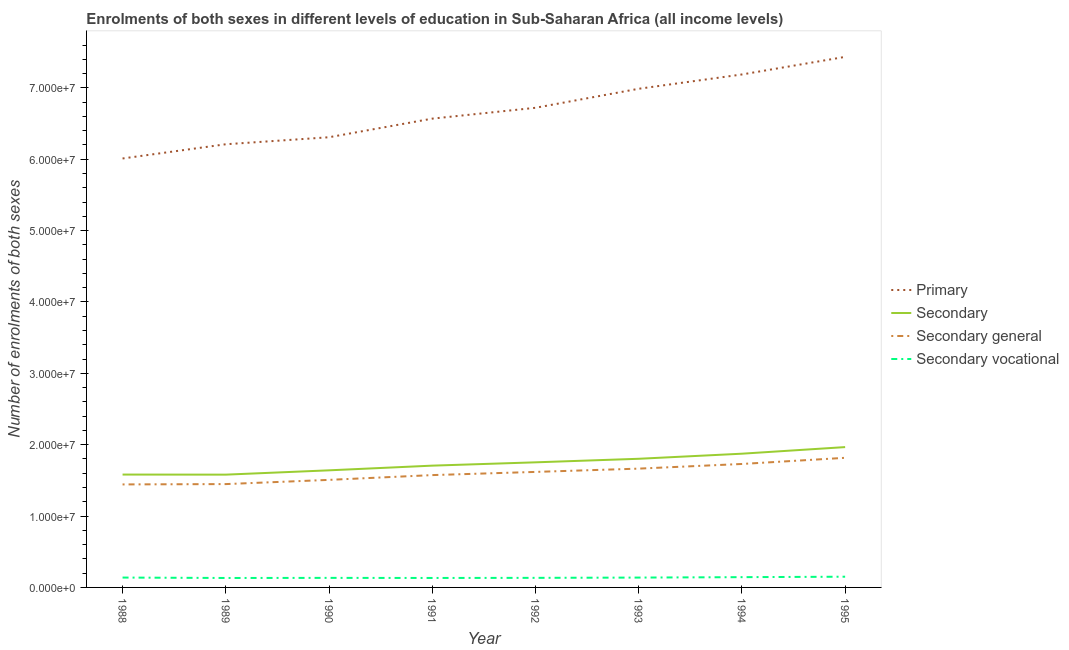What is the number of enrolments in secondary education in 1990?
Make the answer very short. 1.64e+07. Across all years, what is the maximum number of enrolments in secondary vocational education?
Your answer should be compact. 1.50e+06. Across all years, what is the minimum number of enrolments in secondary education?
Keep it short and to the point. 1.58e+07. In which year was the number of enrolments in secondary education minimum?
Provide a succinct answer. 1989. What is the total number of enrolments in secondary vocational education in the graph?
Offer a terse response. 1.10e+07. What is the difference between the number of enrolments in primary education in 1993 and that in 1994?
Give a very brief answer. -2.00e+06. What is the difference between the number of enrolments in secondary education in 1991 and the number of enrolments in primary education in 1995?
Your answer should be compact. -5.73e+07. What is the average number of enrolments in secondary general education per year?
Keep it short and to the point. 1.60e+07. In the year 1992, what is the difference between the number of enrolments in secondary vocational education and number of enrolments in primary education?
Ensure brevity in your answer.  -6.59e+07. In how many years, is the number of enrolments in primary education greater than 26000000?
Give a very brief answer. 8. What is the ratio of the number of enrolments in secondary education in 1988 to that in 1992?
Give a very brief answer. 0.9. What is the difference between the highest and the second highest number of enrolments in secondary vocational education?
Keep it short and to the point. 6.39e+04. What is the difference between the highest and the lowest number of enrolments in secondary general education?
Offer a terse response. 3.73e+06. In how many years, is the number of enrolments in secondary education greater than the average number of enrolments in secondary education taken over all years?
Your response must be concise. 4. Is the sum of the number of enrolments in secondary education in 1988 and 1991 greater than the maximum number of enrolments in secondary general education across all years?
Your answer should be very brief. Yes. Is it the case that in every year, the sum of the number of enrolments in primary education and number of enrolments in secondary vocational education is greater than the sum of number of enrolments in secondary education and number of enrolments in secondary general education?
Give a very brief answer. Yes. Is it the case that in every year, the sum of the number of enrolments in primary education and number of enrolments in secondary education is greater than the number of enrolments in secondary general education?
Your answer should be very brief. Yes. Does the number of enrolments in secondary general education monotonically increase over the years?
Offer a very short reply. Yes. Is the number of enrolments in secondary vocational education strictly greater than the number of enrolments in secondary general education over the years?
Your response must be concise. No. Is the number of enrolments in secondary vocational education strictly less than the number of enrolments in primary education over the years?
Keep it short and to the point. Yes. What is the difference between two consecutive major ticks on the Y-axis?
Keep it short and to the point. 1.00e+07. Are the values on the major ticks of Y-axis written in scientific E-notation?
Keep it short and to the point. Yes. Does the graph contain any zero values?
Offer a terse response. No. How are the legend labels stacked?
Your answer should be compact. Vertical. What is the title of the graph?
Give a very brief answer. Enrolments of both sexes in different levels of education in Sub-Saharan Africa (all income levels). What is the label or title of the X-axis?
Give a very brief answer. Year. What is the label or title of the Y-axis?
Make the answer very short. Number of enrolments of both sexes. What is the Number of enrolments of both sexes of Primary in 1988?
Make the answer very short. 6.01e+07. What is the Number of enrolments of both sexes of Secondary in 1988?
Make the answer very short. 1.58e+07. What is the Number of enrolments of both sexes of Secondary general in 1988?
Provide a succinct answer. 1.44e+07. What is the Number of enrolments of both sexes in Secondary vocational in 1988?
Provide a short and direct response. 1.38e+06. What is the Number of enrolments of both sexes of Primary in 1989?
Your response must be concise. 6.21e+07. What is the Number of enrolments of both sexes of Secondary in 1989?
Provide a short and direct response. 1.58e+07. What is the Number of enrolments of both sexes in Secondary general in 1989?
Your answer should be very brief. 1.45e+07. What is the Number of enrolments of both sexes in Secondary vocational in 1989?
Give a very brief answer. 1.32e+06. What is the Number of enrolments of both sexes of Primary in 1990?
Your response must be concise. 6.31e+07. What is the Number of enrolments of both sexes of Secondary in 1990?
Your answer should be very brief. 1.64e+07. What is the Number of enrolments of both sexes in Secondary general in 1990?
Give a very brief answer. 1.51e+07. What is the Number of enrolments of both sexes of Secondary vocational in 1990?
Offer a very short reply. 1.34e+06. What is the Number of enrolments of both sexes of Primary in 1991?
Your answer should be compact. 6.57e+07. What is the Number of enrolments of both sexes of Secondary in 1991?
Offer a terse response. 1.71e+07. What is the Number of enrolments of both sexes of Secondary general in 1991?
Keep it short and to the point. 1.57e+07. What is the Number of enrolments of both sexes in Secondary vocational in 1991?
Your response must be concise. 1.33e+06. What is the Number of enrolments of both sexes of Primary in 1992?
Provide a succinct answer. 6.72e+07. What is the Number of enrolments of both sexes of Secondary in 1992?
Offer a terse response. 1.75e+07. What is the Number of enrolments of both sexes in Secondary general in 1992?
Offer a very short reply. 1.62e+07. What is the Number of enrolments of both sexes in Secondary vocational in 1992?
Offer a terse response. 1.34e+06. What is the Number of enrolments of both sexes in Primary in 1993?
Your answer should be compact. 6.99e+07. What is the Number of enrolments of both sexes of Secondary in 1993?
Keep it short and to the point. 1.80e+07. What is the Number of enrolments of both sexes in Secondary general in 1993?
Offer a very short reply. 1.66e+07. What is the Number of enrolments of both sexes in Secondary vocational in 1993?
Your response must be concise. 1.38e+06. What is the Number of enrolments of both sexes of Primary in 1994?
Your answer should be compact. 7.19e+07. What is the Number of enrolments of both sexes of Secondary in 1994?
Ensure brevity in your answer.  1.87e+07. What is the Number of enrolments of both sexes of Secondary general in 1994?
Your answer should be very brief. 1.73e+07. What is the Number of enrolments of both sexes in Secondary vocational in 1994?
Make the answer very short. 1.44e+06. What is the Number of enrolments of both sexes of Primary in 1995?
Provide a short and direct response. 7.43e+07. What is the Number of enrolments of both sexes in Secondary in 1995?
Ensure brevity in your answer.  1.97e+07. What is the Number of enrolments of both sexes in Secondary general in 1995?
Make the answer very short. 1.82e+07. What is the Number of enrolments of both sexes in Secondary vocational in 1995?
Provide a succinct answer. 1.50e+06. Across all years, what is the maximum Number of enrolments of both sexes in Primary?
Provide a short and direct response. 7.43e+07. Across all years, what is the maximum Number of enrolments of both sexes of Secondary?
Provide a succinct answer. 1.97e+07. Across all years, what is the maximum Number of enrolments of both sexes in Secondary general?
Offer a terse response. 1.82e+07. Across all years, what is the maximum Number of enrolments of both sexes in Secondary vocational?
Give a very brief answer. 1.50e+06. Across all years, what is the minimum Number of enrolments of both sexes in Primary?
Keep it short and to the point. 6.01e+07. Across all years, what is the minimum Number of enrolments of both sexes of Secondary?
Provide a succinct answer. 1.58e+07. Across all years, what is the minimum Number of enrolments of both sexes in Secondary general?
Keep it short and to the point. 1.44e+07. Across all years, what is the minimum Number of enrolments of both sexes in Secondary vocational?
Provide a succinct answer. 1.32e+06. What is the total Number of enrolments of both sexes of Primary in the graph?
Make the answer very short. 5.34e+08. What is the total Number of enrolments of both sexes of Secondary in the graph?
Ensure brevity in your answer.  1.39e+08. What is the total Number of enrolments of both sexes of Secondary general in the graph?
Make the answer very short. 1.28e+08. What is the total Number of enrolments of both sexes of Secondary vocational in the graph?
Provide a short and direct response. 1.10e+07. What is the difference between the Number of enrolments of both sexes in Primary in 1988 and that in 1989?
Provide a short and direct response. -1.99e+06. What is the difference between the Number of enrolments of both sexes of Secondary in 1988 and that in 1989?
Provide a short and direct response. 1.07e+04. What is the difference between the Number of enrolments of both sexes of Secondary general in 1988 and that in 1989?
Offer a terse response. -4.68e+04. What is the difference between the Number of enrolments of both sexes in Secondary vocational in 1988 and that in 1989?
Your response must be concise. 5.76e+04. What is the difference between the Number of enrolments of both sexes of Primary in 1988 and that in 1990?
Your answer should be very brief. -2.98e+06. What is the difference between the Number of enrolments of both sexes of Secondary in 1988 and that in 1990?
Your answer should be very brief. -5.94e+05. What is the difference between the Number of enrolments of both sexes in Secondary general in 1988 and that in 1990?
Offer a very short reply. -6.37e+05. What is the difference between the Number of enrolments of both sexes of Secondary vocational in 1988 and that in 1990?
Offer a terse response. 4.30e+04. What is the difference between the Number of enrolments of both sexes of Primary in 1988 and that in 1991?
Give a very brief answer. -5.58e+06. What is the difference between the Number of enrolments of both sexes of Secondary in 1988 and that in 1991?
Give a very brief answer. -1.25e+06. What is the difference between the Number of enrolments of both sexes in Secondary general in 1988 and that in 1991?
Keep it short and to the point. -1.31e+06. What is the difference between the Number of enrolments of both sexes of Secondary vocational in 1988 and that in 1991?
Provide a succinct answer. 5.54e+04. What is the difference between the Number of enrolments of both sexes of Primary in 1988 and that in 1992?
Your answer should be very brief. -7.10e+06. What is the difference between the Number of enrolments of both sexes in Secondary in 1988 and that in 1992?
Your answer should be very brief. -1.71e+06. What is the difference between the Number of enrolments of both sexes in Secondary general in 1988 and that in 1992?
Make the answer very short. -1.75e+06. What is the difference between the Number of enrolments of both sexes in Secondary vocational in 1988 and that in 1992?
Your answer should be very brief. 3.94e+04. What is the difference between the Number of enrolments of both sexes of Primary in 1988 and that in 1993?
Offer a very short reply. -9.77e+06. What is the difference between the Number of enrolments of both sexes in Secondary in 1988 and that in 1993?
Your answer should be very brief. -2.21e+06. What is the difference between the Number of enrolments of both sexes in Secondary general in 1988 and that in 1993?
Ensure brevity in your answer.  -2.21e+06. What is the difference between the Number of enrolments of both sexes in Secondary vocational in 1988 and that in 1993?
Provide a short and direct response. 1119.38. What is the difference between the Number of enrolments of both sexes in Primary in 1988 and that in 1994?
Make the answer very short. -1.18e+07. What is the difference between the Number of enrolments of both sexes in Secondary in 1988 and that in 1994?
Keep it short and to the point. -2.92e+06. What is the difference between the Number of enrolments of both sexes of Secondary general in 1988 and that in 1994?
Provide a short and direct response. -2.87e+06. What is the difference between the Number of enrolments of both sexes of Secondary vocational in 1988 and that in 1994?
Your answer should be very brief. -5.75e+04. What is the difference between the Number of enrolments of both sexes in Primary in 1988 and that in 1995?
Your response must be concise. -1.42e+07. What is the difference between the Number of enrolments of both sexes in Secondary in 1988 and that in 1995?
Your answer should be compact. -3.85e+06. What is the difference between the Number of enrolments of both sexes in Secondary general in 1988 and that in 1995?
Your response must be concise. -3.73e+06. What is the difference between the Number of enrolments of both sexes in Secondary vocational in 1988 and that in 1995?
Offer a terse response. -1.21e+05. What is the difference between the Number of enrolments of both sexes in Primary in 1989 and that in 1990?
Your response must be concise. -9.83e+05. What is the difference between the Number of enrolments of both sexes in Secondary in 1989 and that in 1990?
Offer a terse response. -6.05e+05. What is the difference between the Number of enrolments of both sexes of Secondary general in 1989 and that in 1990?
Provide a succinct answer. -5.90e+05. What is the difference between the Number of enrolments of both sexes of Secondary vocational in 1989 and that in 1990?
Provide a short and direct response. -1.46e+04. What is the difference between the Number of enrolments of both sexes in Primary in 1989 and that in 1991?
Make the answer very short. -3.59e+06. What is the difference between the Number of enrolments of both sexes in Secondary in 1989 and that in 1991?
Give a very brief answer. -1.26e+06. What is the difference between the Number of enrolments of both sexes in Secondary general in 1989 and that in 1991?
Ensure brevity in your answer.  -1.26e+06. What is the difference between the Number of enrolments of both sexes in Secondary vocational in 1989 and that in 1991?
Offer a terse response. -2124.88. What is the difference between the Number of enrolments of both sexes of Primary in 1989 and that in 1992?
Your answer should be very brief. -5.11e+06. What is the difference between the Number of enrolments of both sexes of Secondary in 1989 and that in 1992?
Provide a succinct answer. -1.72e+06. What is the difference between the Number of enrolments of both sexes in Secondary general in 1989 and that in 1992?
Your response must be concise. -1.71e+06. What is the difference between the Number of enrolments of both sexes in Secondary vocational in 1989 and that in 1992?
Your response must be concise. -1.82e+04. What is the difference between the Number of enrolments of both sexes in Primary in 1989 and that in 1993?
Give a very brief answer. -7.78e+06. What is the difference between the Number of enrolments of both sexes in Secondary in 1989 and that in 1993?
Make the answer very short. -2.22e+06. What is the difference between the Number of enrolments of both sexes in Secondary general in 1989 and that in 1993?
Make the answer very short. -2.17e+06. What is the difference between the Number of enrolments of both sexes in Secondary vocational in 1989 and that in 1993?
Keep it short and to the point. -5.65e+04. What is the difference between the Number of enrolments of both sexes of Primary in 1989 and that in 1994?
Give a very brief answer. -9.78e+06. What is the difference between the Number of enrolments of both sexes of Secondary in 1989 and that in 1994?
Offer a very short reply. -2.93e+06. What is the difference between the Number of enrolments of both sexes in Secondary general in 1989 and that in 1994?
Provide a short and direct response. -2.82e+06. What is the difference between the Number of enrolments of both sexes in Secondary vocational in 1989 and that in 1994?
Your answer should be compact. -1.15e+05. What is the difference between the Number of enrolments of both sexes in Primary in 1989 and that in 1995?
Provide a short and direct response. -1.22e+07. What is the difference between the Number of enrolments of both sexes in Secondary in 1989 and that in 1995?
Provide a short and direct response. -3.86e+06. What is the difference between the Number of enrolments of both sexes in Secondary general in 1989 and that in 1995?
Provide a short and direct response. -3.68e+06. What is the difference between the Number of enrolments of both sexes of Secondary vocational in 1989 and that in 1995?
Give a very brief answer. -1.79e+05. What is the difference between the Number of enrolments of both sexes in Primary in 1990 and that in 1991?
Offer a terse response. -2.61e+06. What is the difference between the Number of enrolments of both sexes in Secondary in 1990 and that in 1991?
Offer a very short reply. -6.57e+05. What is the difference between the Number of enrolments of both sexes of Secondary general in 1990 and that in 1991?
Provide a succinct answer. -6.69e+05. What is the difference between the Number of enrolments of both sexes in Secondary vocational in 1990 and that in 1991?
Offer a terse response. 1.25e+04. What is the difference between the Number of enrolments of both sexes of Primary in 1990 and that in 1992?
Give a very brief answer. -4.13e+06. What is the difference between the Number of enrolments of both sexes of Secondary in 1990 and that in 1992?
Provide a short and direct response. -1.12e+06. What is the difference between the Number of enrolments of both sexes in Secondary general in 1990 and that in 1992?
Give a very brief answer. -1.12e+06. What is the difference between the Number of enrolments of both sexes of Secondary vocational in 1990 and that in 1992?
Your response must be concise. -3545.75. What is the difference between the Number of enrolments of both sexes in Primary in 1990 and that in 1993?
Provide a short and direct response. -6.79e+06. What is the difference between the Number of enrolments of both sexes in Secondary in 1990 and that in 1993?
Ensure brevity in your answer.  -1.62e+06. What is the difference between the Number of enrolments of both sexes in Secondary general in 1990 and that in 1993?
Offer a very short reply. -1.58e+06. What is the difference between the Number of enrolments of both sexes of Secondary vocational in 1990 and that in 1993?
Provide a short and direct response. -4.18e+04. What is the difference between the Number of enrolments of both sexes of Primary in 1990 and that in 1994?
Provide a succinct answer. -8.80e+06. What is the difference between the Number of enrolments of both sexes of Secondary in 1990 and that in 1994?
Your answer should be compact. -2.33e+06. What is the difference between the Number of enrolments of both sexes in Secondary general in 1990 and that in 1994?
Provide a succinct answer. -2.23e+06. What is the difference between the Number of enrolments of both sexes of Secondary vocational in 1990 and that in 1994?
Keep it short and to the point. -1.00e+05. What is the difference between the Number of enrolments of both sexes in Primary in 1990 and that in 1995?
Your answer should be very brief. -1.13e+07. What is the difference between the Number of enrolments of both sexes of Secondary in 1990 and that in 1995?
Your answer should be compact. -3.26e+06. What is the difference between the Number of enrolments of both sexes in Secondary general in 1990 and that in 1995?
Make the answer very short. -3.09e+06. What is the difference between the Number of enrolments of both sexes in Secondary vocational in 1990 and that in 1995?
Your answer should be very brief. -1.64e+05. What is the difference between the Number of enrolments of both sexes in Primary in 1991 and that in 1992?
Your answer should be compact. -1.52e+06. What is the difference between the Number of enrolments of both sexes in Secondary in 1991 and that in 1992?
Provide a short and direct response. -4.63e+05. What is the difference between the Number of enrolments of both sexes in Secondary general in 1991 and that in 1992?
Keep it short and to the point. -4.47e+05. What is the difference between the Number of enrolments of both sexes of Secondary vocational in 1991 and that in 1992?
Provide a succinct answer. -1.60e+04. What is the difference between the Number of enrolments of both sexes of Primary in 1991 and that in 1993?
Your response must be concise. -4.18e+06. What is the difference between the Number of enrolments of both sexes in Secondary in 1991 and that in 1993?
Your response must be concise. -9.61e+05. What is the difference between the Number of enrolments of both sexes of Secondary general in 1991 and that in 1993?
Keep it short and to the point. -9.07e+05. What is the difference between the Number of enrolments of both sexes in Secondary vocational in 1991 and that in 1993?
Ensure brevity in your answer.  -5.43e+04. What is the difference between the Number of enrolments of both sexes of Primary in 1991 and that in 1994?
Provide a succinct answer. -6.19e+06. What is the difference between the Number of enrolments of both sexes in Secondary in 1991 and that in 1994?
Provide a succinct answer. -1.67e+06. What is the difference between the Number of enrolments of both sexes in Secondary general in 1991 and that in 1994?
Your answer should be compact. -1.56e+06. What is the difference between the Number of enrolments of both sexes in Secondary vocational in 1991 and that in 1994?
Your response must be concise. -1.13e+05. What is the difference between the Number of enrolments of both sexes in Primary in 1991 and that in 1995?
Ensure brevity in your answer.  -8.65e+06. What is the difference between the Number of enrolments of both sexes in Secondary in 1991 and that in 1995?
Provide a succinct answer. -2.60e+06. What is the difference between the Number of enrolments of both sexes in Secondary general in 1991 and that in 1995?
Make the answer very short. -2.42e+06. What is the difference between the Number of enrolments of both sexes of Secondary vocational in 1991 and that in 1995?
Make the answer very short. -1.77e+05. What is the difference between the Number of enrolments of both sexes of Primary in 1992 and that in 1993?
Offer a very short reply. -2.67e+06. What is the difference between the Number of enrolments of both sexes in Secondary in 1992 and that in 1993?
Offer a very short reply. -4.99e+05. What is the difference between the Number of enrolments of both sexes in Secondary general in 1992 and that in 1993?
Give a very brief answer. -4.60e+05. What is the difference between the Number of enrolments of both sexes in Secondary vocational in 1992 and that in 1993?
Keep it short and to the point. -3.83e+04. What is the difference between the Number of enrolments of both sexes in Primary in 1992 and that in 1994?
Offer a very short reply. -4.67e+06. What is the difference between the Number of enrolments of both sexes of Secondary in 1992 and that in 1994?
Your answer should be very brief. -1.21e+06. What is the difference between the Number of enrolments of both sexes of Secondary general in 1992 and that in 1994?
Provide a short and direct response. -1.11e+06. What is the difference between the Number of enrolments of both sexes of Secondary vocational in 1992 and that in 1994?
Keep it short and to the point. -9.69e+04. What is the difference between the Number of enrolments of both sexes in Primary in 1992 and that in 1995?
Your answer should be compact. -7.13e+06. What is the difference between the Number of enrolments of both sexes of Secondary in 1992 and that in 1995?
Provide a succinct answer. -2.14e+06. What is the difference between the Number of enrolments of both sexes in Secondary general in 1992 and that in 1995?
Give a very brief answer. -1.98e+06. What is the difference between the Number of enrolments of both sexes of Secondary vocational in 1992 and that in 1995?
Your answer should be compact. -1.61e+05. What is the difference between the Number of enrolments of both sexes of Primary in 1993 and that in 1994?
Ensure brevity in your answer.  -2.00e+06. What is the difference between the Number of enrolments of both sexes of Secondary in 1993 and that in 1994?
Offer a terse response. -7.12e+05. What is the difference between the Number of enrolments of both sexes of Secondary general in 1993 and that in 1994?
Give a very brief answer. -6.54e+05. What is the difference between the Number of enrolments of both sexes in Secondary vocational in 1993 and that in 1994?
Provide a short and direct response. -5.86e+04. What is the difference between the Number of enrolments of both sexes in Primary in 1993 and that in 1995?
Your response must be concise. -4.47e+06. What is the difference between the Number of enrolments of both sexes in Secondary in 1993 and that in 1995?
Your answer should be very brief. -1.64e+06. What is the difference between the Number of enrolments of both sexes of Secondary general in 1993 and that in 1995?
Ensure brevity in your answer.  -1.52e+06. What is the difference between the Number of enrolments of both sexes in Secondary vocational in 1993 and that in 1995?
Provide a succinct answer. -1.23e+05. What is the difference between the Number of enrolments of both sexes of Primary in 1994 and that in 1995?
Keep it short and to the point. -2.46e+06. What is the difference between the Number of enrolments of both sexes in Secondary in 1994 and that in 1995?
Make the answer very short. -9.25e+05. What is the difference between the Number of enrolments of both sexes of Secondary general in 1994 and that in 1995?
Offer a terse response. -8.62e+05. What is the difference between the Number of enrolments of both sexes in Secondary vocational in 1994 and that in 1995?
Give a very brief answer. -6.39e+04. What is the difference between the Number of enrolments of both sexes in Primary in 1988 and the Number of enrolments of both sexes in Secondary in 1989?
Your answer should be compact. 4.43e+07. What is the difference between the Number of enrolments of both sexes of Primary in 1988 and the Number of enrolments of both sexes of Secondary general in 1989?
Provide a succinct answer. 4.56e+07. What is the difference between the Number of enrolments of both sexes of Primary in 1988 and the Number of enrolments of both sexes of Secondary vocational in 1989?
Keep it short and to the point. 5.88e+07. What is the difference between the Number of enrolments of both sexes in Secondary in 1988 and the Number of enrolments of both sexes in Secondary general in 1989?
Offer a very short reply. 1.33e+06. What is the difference between the Number of enrolments of both sexes in Secondary in 1988 and the Number of enrolments of both sexes in Secondary vocational in 1989?
Keep it short and to the point. 1.45e+07. What is the difference between the Number of enrolments of both sexes in Secondary general in 1988 and the Number of enrolments of both sexes in Secondary vocational in 1989?
Your answer should be very brief. 1.31e+07. What is the difference between the Number of enrolments of both sexes in Primary in 1988 and the Number of enrolments of both sexes in Secondary in 1990?
Provide a short and direct response. 4.37e+07. What is the difference between the Number of enrolments of both sexes in Primary in 1988 and the Number of enrolments of both sexes in Secondary general in 1990?
Give a very brief answer. 4.50e+07. What is the difference between the Number of enrolments of both sexes of Primary in 1988 and the Number of enrolments of both sexes of Secondary vocational in 1990?
Your answer should be very brief. 5.88e+07. What is the difference between the Number of enrolments of both sexes of Secondary in 1988 and the Number of enrolments of both sexes of Secondary general in 1990?
Provide a short and direct response. 7.44e+05. What is the difference between the Number of enrolments of both sexes of Secondary in 1988 and the Number of enrolments of both sexes of Secondary vocational in 1990?
Offer a terse response. 1.45e+07. What is the difference between the Number of enrolments of both sexes in Secondary general in 1988 and the Number of enrolments of both sexes in Secondary vocational in 1990?
Give a very brief answer. 1.31e+07. What is the difference between the Number of enrolments of both sexes of Primary in 1988 and the Number of enrolments of both sexes of Secondary in 1991?
Provide a succinct answer. 4.30e+07. What is the difference between the Number of enrolments of both sexes of Primary in 1988 and the Number of enrolments of both sexes of Secondary general in 1991?
Your answer should be compact. 4.44e+07. What is the difference between the Number of enrolments of both sexes of Primary in 1988 and the Number of enrolments of both sexes of Secondary vocational in 1991?
Ensure brevity in your answer.  5.88e+07. What is the difference between the Number of enrolments of both sexes of Secondary in 1988 and the Number of enrolments of both sexes of Secondary general in 1991?
Your answer should be very brief. 7.54e+04. What is the difference between the Number of enrolments of both sexes of Secondary in 1988 and the Number of enrolments of both sexes of Secondary vocational in 1991?
Make the answer very short. 1.45e+07. What is the difference between the Number of enrolments of both sexes of Secondary general in 1988 and the Number of enrolments of both sexes of Secondary vocational in 1991?
Offer a terse response. 1.31e+07. What is the difference between the Number of enrolments of both sexes of Primary in 1988 and the Number of enrolments of both sexes of Secondary in 1992?
Ensure brevity in your answer.  4.26e+07. What is the difference between the Number of enrolments of both sexes in Primary in 1988 and the Number of enrolments of both sexes in Secondary general in 1992?
Your answer should be very brief. 4.39e+07. What is the difference between the Number of enrolments of both sexes of Primary in 1988 and the Number of enrolments of both sexes of Secondary vocational in 1992?
Your response must be concise. 5.88e+07. What is the difference between the Number of enrolments of both sexes in Secondary in 1988 and the Number of enrolments of both sexes in Secondary general in 1992?
Provide a succinct answer. -3.71e+05. What is the difference between the Number of enrolments of both sexes of Secondary in 1988 and the Number of enrolments of both sexes of Secondary vocational in 1992?
Offer a terse response. 1.45e+07. What is the difference between the Number of enrolments of both sexes of Secondary general in 1988 and the Number of enrolments of both sexes of Secondary vocational in 1992?
Make the answer very short. 1.31e+07. What is the difference between the Number of enrolments of both sexes of Primary in 1988 and the Number of enrolments of both sexes of Secondary in 1993?
Your answer should be compact. 4.21e+07. What is the difference between the Number of enrolments of both sexes of Primary in 1988 and the Number of enrolments of both sexes of Secondary general in 1993?
Ensure brevity in your answer.  4.35e+07. What is the difference between the Number of enrolments of both sexes of Primary in 1988 and the Number of enrolments of both sexes of Secondary vocational in 1993?
Make the answer very short. 5.87e+07. What is the difference between the Number of enrolments of both sexes of Secondary in 1988 and the Number of enrolments of both sexes of Secondary general in 1993?
Provide a succinct answer. -8.32e+05. What is the difference between the Number of enrolments of both sexes of Secondary in 1988 and the Number of enrolments of both sexes of Secondary vocational in 1993?
Provide a short and direct response. 1.44e+07. What is the difference between the Number of enrolments of both sexes in Secondary general in 1988 and the Number of enrolments of both sexes in Secondary vocational in 1993?
Keep it short and to the point. 1.31e+07. What is the difference between the Number of enrolments of both sexes in Primary in 1988 and the Number of enrolments of both sexes in Secondary in 1994?
Your answer should be very brief. 4.14e+07. What is the difference between the Number of enrolments of both sexes in Primary in 1988 and the Number of enrolments of both sexes in Secondary general in 1994?
Offer a terse response. 4.28e+07. What is the difference between the Number of enrolments of both sexes in Primary in 1988 and the Number of enrolments of both sexes in Secondary vocational in 1994?
Your response must be concise. 5.87e+07. What is the difference between the Number of enrolments of both sexes of Secondary in 1988 and the Number of enrolments of both sexes of Secondary general in 1994?
Your answer should be very brief. -1.49e+06. What is the difference between the Number of enrolments of both sexes in Secondary in 1988 and the Number of enrolments of both sexes in Secondary vocational in 1994?
Provide a succinct answer. 1.44e+07. What is the difference between the Number of enrolments of both sexes in Secondary general in 1988 and the Number of enrolments of both sexes in Secondary vocational in 1994?
Offer a very short reply. 1.30e+07. What is the difference between the Number of enrolments of both sexes in Primary in 1988 and the Number of enrolments of both sexes in Secondary in 1995?
Your answer should be very brief. 4.04e+07. What is the difference between the Number of enrolments of both sexes in Primary in 1988 and the Number of enrolments of both sexes in Secondary general in 1995?
Give a very brief answer. 4.19e+07. What is the difference between the Number of enrolments of both sexes of Primary in 1988 and the Number of enrolments of both sexes of Secondary vocational in 1995?
Provide a short and direct response. 5.86e+07. What is the difference between the Number of enrolments of both sexes in Secondary in 1988 and the Number of enrolments of both sexes in Secondary general in 1995?
Your answer should be very brief. -2.35e+06. What is the difference between the Number of enrolments of both sexes of Secondary in 1988 and the Number of enrolments of both sexes of Secondary vocational in 1995?
Your answer should be compact. 1.43e+07. What is the difference between the Number of enrolments of both sexes of Secondary general in 1988 and the Number of enrolments of both sexes of Secondary vocational in 1995?
Offer a terse response. 1.29e+07. What is the difference between the Number of enrolments of both sexes of Primary in 1989 and the Number of enrolments of both sexes of Secondary in 1990?
Provide a succinct answer. 4.57e+07. What is the difference between the Number of enrolments of both sexes of Primary in 1989 and the Number of enrolments of both sexes of Secondary general in 1990?
Make the answer very short. 4.70e+07. What is the difference between the Number of enrolments of both sexes of Primary in 1989 and the Number of enrolments of both sexes of Secondary vocational in 1990?
Ensure brevity in your answer.  6.08e+07. What is the difference between the Number of enrolments of both sexes of Secondary in 1989 and the Number of enrolments of both sexes of Secondary general in 1990?
Provide a short and direct response. 7.34e+05. What is the difference between the Number of enrolments of both sexes in Secondary in 1989 and the Number of enrolments of both sexes in Secondary vocational in 1990?
Offer a terse response. 1.45e+07. What is the difference between the Number of enrolments of both sexes in Secondary general in 1989 and the Number of enrolments of both sexes in Secondary vocational in 1990?
Give a very brief answer. 1.31e+07. What is the difference between the Number of enrolments of both sexes in Primary in 1989 and the Number of enrolments of both sexes in Secondary in 1991?
Your answer should be compact. 4.50e+07. What is the difference between the Number of enrolments of both sexes in Primary in 1989 and the Number of enrolments of both sexes in Secondary general in 1991?
Your answer should be compact. 4.64e+07. What is the difference between the Number of enrolments of both sexes of Primary in 1989 and the Number of enrolments of both sexes of Secondary vocational in 1991?
Your answer should be compact. 6.08e+07. What is the difference between the Number of enrolments of both sexes in Secondary in 1989 and the Number of enrolments of both sexes in Secondary general in 1991?
Keep it short and to the point. 6.46e+04. What is the difference between the Number of enrolments of both sexes of Secondary in 1989 and the Number of enrolments of both sexes of Secondary vocational in 1991?
Provide a short and direct response. 1.45e+07. What is the difference between the Number of enrolments of both sexes in Secondary general in 1989 and the Number of enrolments of both sexes in Secondary vocational in 1991?
Your answer should be compact. 1.32e+07. What is the difference between the Number of enrolments of both sexes of Primary in 1989 and the Number of enrolments of both sexes of Secondary in 1992?
Make the answer very short. 4.46e+07. What is the difference between the Number of enrolments of both sexes in Primary in 1989 and the Number of enrolments of both sexes in Secondary general in 1992?
Your response must be concise. 4.59e+07. What is the difference between the Number of enrolments of both sexes of Primary in 1989 and the Number of enrolments of both sexes of Secondary vocational in 1992?
Offer a terse response. 6.08e+07. What is the difference between the Number of enrolments of both sexes in Secondary in 1989 and the Number of enrolments of both sexes in Secondary general in 1992?
Your answer should be compact. -3.82e+05. What is the difference between the Number of enrolments of both sexes in Secondary in 1989 and the Number of enrolments of both sexes in Secondary vocational in 1992?
Provide a short and direct response. 1.45e+07. What is the difference between the Number of enrolments of both sexes of Secondary general in 1989 and the Number of enrolments of both sexes of Secondary vocational in 1992?
Give a very brief answer. 1.31e+07. What is the difference between the Number of enrolments of both sexes in Primary in 1989 and the Number of enrolments of both sexes in Secondary in 1993?
Keep it short and to the point. 4.41e+07. What is the difference between the Number of enrolments of both sexes of Primary in 1989 and the Number of enrolments of both sexes of Secondary general in 1993?
Your answer should be compact. 4.55e+07. What is the difference between the Number of enrolments of both sexes of Primary in 1989 and the Number of enrolments of both sexes of Secondary vocational in 1993?
Keep it short and to the point. 6.07e+07. What is the difference between the Number of enrolments of both sexes of Secondary in 1989 and the Number of enrolments of both sexes of Secondary general in 1993?
Make the answer very short. -8.42e+05. What is the difference between the Number of enrolments of both sexes in Secondary in 1989 and the Number of enrolments of both sexes in Secondary vocational in 1993?
Provide a short and direct response. 1.44e+07. What is the difference between the Number of enrolments of both sexes of Secondary general in 1989 and the Number of enrolments of both sexes of Secondary vocational in 1993?
Offer a very short reply. 1.31e+07. What is the difference between the Number of enrolments of both sexes in Primary in 1989 and the Number of enrolments of both sexes in Secondary in 1994?
Ensure brevity in your answer.  4.34e+07. What is the difference between the Number of enrolments of both sexes in Primary in 1989 and the Number of enrolments of both sexes in Secondary general in 1994?
Your answer should be very brief. 4.48e+07. What is the difference between the Number of enrolments of both sexes in Primary in 1989 and the Number of enrolments of both sexes in Secondary vocational in 1994?
Offer a very short reply. 6.07e+07. What is the difference between the Number of enrolments of both sexes of Secondary in 1989 and the Number of enrolments of both sexes of Secondary general in 1994?
Make the answer very short. -1.50e+06. What is the difference between the Number of enrolments of both sexes of Secondary in 1989 and the Number of enrolments of both sexes of Secondary vocational in 1994?
Your answer should be compact. 1.44e+07. What is the difference between the Number of enrolments of both sexes of Secondary general in 1989 and the Number of enrolments of both sexes of Secondary vocational in 1994?
Ensure brevity in your answer.  1.30e+07. What is the difference between the Number of enrolments of both sexes in Primary in 1989 and the Number of enrolments of both sexes in Secondary in 1995?
Keep it short and to the point. 4.24e+07. What is the difference between the Number of enrolments of both sexes in Primary in 1989 and the Number of enrolments of both sexes in Secondary general in 1995?
Ensure brevity in your answer.  4.39e+07. What is the difference between the Number of enrolments of both sexes of Primary in 1989 and the Number of enrolments of both sexes of Secondary vocational in 1995?
Make the answer very short. 6.06e+07. What is the difference between the Number of enrolments of both sexes of Secondary in 1989 and the Number of enrolments of both sexes of Secondary general in 1995?
Keep it short and to the point. -2.36e+06. What is the difference between the Number of enrolments of both sexes of Secondary in 1989 and the Number of enrolments of both sexes of Secondary vocational in 1995?
Offer a very short reply. 1.43e+07. What is the difference between the Number of enrolments of both sexes in Secondary general in 1989 and the Number of enrolments of both sexes in Secondary vocational in 1995?
Offer a terse response. 1.30e+07. What is the difference between the Number of enrolments of both sexes of Primary in 1990 and the Number of enrolments of both sexes of Secondary in 1991?
Make the answer very short. 4.60e+07. What is the difference between the Number of enrolments of both sexes of Primary in 1990 and the Number of enrolments of both sexes of Secondary general in 1991?
Ensure brevity in your answer.  4.73e+07. What is the difference between the Number of enrolments of both sexes of Primary in 1990 and the Number of enrolments of both sexes of Secondary vocational in 1991?
Ensure brevity in your answer.  6.18e+07. What is the difference between the Number of enrolments of both sexes of Secondary in 1990 and the Number of enrolments of both sexes of Secondary general in 1991?
Provide a succinct answer. 6.69e+05. What is the difference between the Number of enrolments of both sexes of Secondary in 1990 and the Number of enrolments of both sexes of Secondary vocational in 1991?
Give a very brief answer. 1.51e+07. What is the difference between the Number of enrolments of both sexes in Secondary general in 1990 and the Number of enrolments of both sexes in Secondary vocational in 1991?
Offer a very short reply. 1.37e+07. What is the difference between the Number of enrolments of both sexes of Primary in 1990 and the Number of enrolments of both sexes of Secondary in 1992?
Your answer should be compact. 4.56e+07. What is the difference between the Number of enrolments of both sexes of Primary in 1990 and the Number of enrolments of both sexes of Secondary general in 1992?
Your answer should be compact. 4.69e+07. What is the difference between the Number of enrolments of both sexes of Primary in 1990 and the Number of enrolments of both sexes of Secondary vocational in 1992?
Your answer should be compact. 6.17e+07. What is the difference between the Number of enrolments of both sexes of Secondary in 1990 and the Number of enrolments of both sexes of Secondary general in 1992?
Offer a very short reply. 2.23e+05. What is the difference between the Number of enrolments of both sexes of Secondary in 1990 and the Number of enrolments of both sexes of Secondary vocational in 1992?
Your response must be concise. 1.51e+07. What is the difference between the Number of enrolments of both sexes in Secondary general in 1990 and the Number of enrolments of both sexes in Secondary vocational in 1992?
Your answer should be very brief. 1.37e+07. What is the difference between the Number of enrolments of both sexes in Primary in 1990 and the Number of enrolments of both sexes in Secondary in 1993?
Provide a short and direct response. 4.51e+07. What is the difference between the Number of enrolments of both sexes of Primary in 1990 and the Number of enrolments of both sexes of Secondary general in 1993?
Your answer should be very brief. 4.64e+07. What is the difference between the Number of enrolments of both sexes in Primary in 1990 and the Number of enrolments of both sexes in Secondary vocational in 1993?
Keep it short and to the point. 6.17e+07. What is the difference between the Number of enrolments of both sexes of Secondary in 1990 and the Number of enrolments of both sexes of Secondary general in 1993?
Offer a very short reply. -2.38e+05. What is the difference between the Number of enrolments of both sexes of Secondary in 1990 and the Number of enrolments of both sexes of Secondary vocational in 1993?
Keep it short and to the point. 1.50e+07. What is the difference between the Number of enrolments of both sexes in Secondary general in 1990 and the Number of enrolments of both sexes in Secondary vocational in 1993?
Your response must be concise. 1.37e+07. What is the difference between the Number of enrolments of both sexes in Primary in 1990 and the Number of enrolments of both sexes in Secondary in 1994?
Give a very brief answer. 4.43e+07. What is the difference between the Number of enrolments of both sexes in Primary in 1990 and the Number of enrolments of both sexes in Secondary general in 1994?
Make the answer very short. 4.58e+07. What is the difference between the Number of enrolments of both sexes of Primary in 1990 and the Number of enrolments of both sexes of Secondary vocational in 1994?
Your answer should be very brief. 6.16e+07. What is the difference between the Number of enrolments of both sexes of Secondary in 1990 and the Number of enrolments of both sexes of Secondary general in 1994?
Keep it short and to the point. -8.91e+05. What is the difference between the Number of enrolments of both sexes of Secondary in 1990 and the Number of enrolments of both sexes of Secondary vocational in 1994?
Ensure brevity in your answer.  1.50e+07. What is the difference between the Number of enrolments of both sexes in Secondary general in 1990 and the Number of enrolments of both sexes in Secondary vocational in 1994?
Ensure brevity in your answer.  1.36e+07. What is the difference between the Number of enrolments of both sexes of Primary in 1990 and the Number of enrolments of both sexes of Secondary in 1995?
Your answer should be compact. 4.34e+07. What is the difference between the Number of enrolments of both sexes of Primary in 1990 and the Number of enrolments of both sexes of Secondary general in 1995?
Offer a very short reply. 4.49e+07. What is the difference between the Number of enrolments of both sexes of Primary in 1990 and the Number of enrolments of both sexes of Secondary vocational in 1995?
Your response must be concise. 6.16e+07. What is the difference between the Number of enrolments of both sexes in Secondary in 1990 and the Number of enrolments of both sexes in Secondary general in 1995?
Give a very brief answer. -1.75e+06. What is the difference between the Number of enrolments of both sexes in Secondary in 1990 and the Number of enrolments of both sexes in Secondary vocational in 1995?
Provide a succinct answer. 1.49e+07. What is the difference between the Number of enrolments of both sexes of Secondary general in 1990 and the Number of enrolments of both sexes of Secondary vocational in 1995?
Offer a terse response. 1.36e+07. What is the difference between the Number of enrolments of both sexes in Primary in 1991 and the Number of enrolments of both sexes in Secondary in 1992?
Offer a terse response. 4.82e+07. What is the difference between the Number of enrolments of both sexes of Primary in 1991 and the Number of enrolments of both sexes of Secondary general in 1992?
Make the answer very short. 4.95e+07. What is the difference between the Number of enrolments of both sexes in Primary in 1991 and the Number of enrolments of both sexes in Secondary vocational in 1992?
Ensure brevity in your answer.  6.43e+07. What is the difference between the Number of enrolments of both sexes of Secondary in 1991 and the Number of enrolments of both sexes of Secondary general in 1992?
Offer a terse response. 8.79e+05. What is the difference between the Number of enrolments of both sexes of Secondary in 1991 and the Number of enrolments of both sexes of Secondary vocational in 1992?
Your response must be concise. 1.57e+07. What is the difference between the Number of enrolments of both sexes in Secondary general in 1991 and the Number of enrolments of both sexes in Secondary vocational in 1992?
Offer a very short reply. 1.44e+07. What is the difference between the Number of enrolments of both sexes in Primary in 1991 and the Number of enrolments of both sexes in Secondary in 1993?
Your answer should be compact. 4.77e+07. What is the difference between the Number of enrolments of both sexes in Primary in 1991 and the Number of enrolments of both sexes in Secondary general in 1993?
Keep it short and to the point. 4.90e+07. What is the difference between the Number of enrolments of both sexes in Primary in 1991 and the Number of enrolments of both sexes in Secondary vocational in 1993?
Provide a short and direct response. 6.43e+07. What is the difference between the Number of enrolments of both sexes in Secondary in 1991 and the Number of enrolments of both sexes in Secondary general in 1993?
Your answer should be compact. 4.19e+05. What is the difference between the Number of enrolments of both sexes of Secondary in 1991 and the Number of enrolments of both sexes of Secondary vocational in 1993?
Your answer should be very brief. 1.57e+07. What is the difference between the Number of enrolments of both sexes in Secondary general in 1991 and the Number of enrolments of both sexes in Secondary vocational in 1993?
Your response must be concise. 1.44e+07. What is the difference between the Number of enrolments of both sexes of Primary in 1991 and the Number of enrolments of both sexes of Secondary in 1994?
Offer a very short reply. 4.70e+07. What is the difference between the Number of enrolments of both sexes of Primary in 1991 and the Number of enrolments of both sexes of Secondary general in 1994?
Offer a very short reply. 4.84e+07. What is the difference between the Number of enrolments of both sexes in Primary in 1991 and the Number of enrolments of both sexes in Secondary vocational in 1994?
Your answer should be very brief. 6.43e+07. What is the difference between the Number of enrolments of both sexes in Secondary in 1991 and the Number of enrolments of both sexes in Secondary general in 1994?
Your response must be concise. -2.35e+05. What is the difference between the Number of enrolments of both sexes in Secondary in 1991 and the Number of enrolments of both sexes in Secondary vocational in 1994?
Make the answer very short. 1.56e+07. What is the difference between the Number of enrolments of both sexes in Secondary general in 1991 and the Number of enrolments of both sexes in Secondary vocational in 1994?
Your response must be concise. 1.43e+07. What is the difference between the Number of enrolments of both sexes in Primary in 1991 and the Number of enrolments of both sexes in Secondary in 1995?
Offer a terse response. 4.60e+07. What is the difference between the Number of enrolments of both sexes of Primary in 1991 and the Number of enrolments of both sexes of Secondary general in 1995?
Offer a terse response. 4.75e+07. What is the difference between the Number of enrolments of both sexes in Primary in 1991 and the Number of enrolments of both sexes in Secondary vocational in 1995?
Keep it short and to the point. 6.42e+07. What is the difference between the Number of enrolments of both sexes of Secondary in 1991 and the Number of enrolments of both sexes of Secondary general in 1995?
Give a very brief answer. -1.10e+06. What is the difference between the Number of enrolments of both sexes of Secondary in 1991 and the Number of enrolments of both sexes of Secondary vocational in 1995?
Your response must be concise. 1.56e+07. What is the difference between the Number of enrolments of both sexes in Secondary general in 1991 and the Number of enrolments of both sexes in Secondary vocational in 1995?
Your answer should be compact. 1.42e+07. What is the difference between the Number of enrolments of both sexes of Primary in 1992 and the Number of enrolments of both sexes of Secondary in 1993?
Your answer should be very brief. 4.92e+07. What is the difference between the Number of enrolments of both sexes of Primary in 1992 and the Number of enrolments of both sexes of Secondary general in 1993?
Provide a succinct answer. 5.06e+07. What is the difference between the Number of enrolments of both sexes in Primary in 1992 and the Number of enrolments of both sexes in Secondary vocational in 1993?
Your answer should be very brief. 6.58e+07. What is the difference between the Number of enrolments of both sexes in Secondary in 1992 and the Number of enrolments of both sexes in Secondary general in 1993?
Ensure brevity in your answer.  8.82e+05. What is the difference between the Number of enrolments of both sexes in Secondary in 1992 and the Number of enrolments of both sexes in Secondary vocational in 1993?
Offer a very short reply. 1.61e+07. What is the difference between the Number of enrolments of both sexes in Secondary general in 1992 and the Number of enrolments of both sexes in Secondary vocational in 1993?
Your response must be concise. 1.48e+07. What is the difference between the Number of enrolments of both sexes of Primary in 1992 and the Number of enrolments of both sexes of Secondary in 1994?
Give a very brief answer. 4.85e+07. What is the difference between the Number of enrolments of both sexes in Primary in 1992 and the Number of enrolments of both sexes in Secondary general in 1994?
Provide a succinct answer. 4.99e+07. What is the difference between the Number of enrolments of both sexes of Primary in 1992 and the Number of enrolments of both sexes of Secondary vocational in 1994?
Offer a very short reply. 6.58e+07. What is the difference between the Number of enrolments of both sexes of Secondary in 1992 and the Number of enrolments of both sexes of Secondary general in 1994?
Provide a short and direct response. 2.28e+05. What is the difference between the Number of enrolments of both sexes in Secondary in 1992 and the Number of enrolments of both sexes in Secondary vocational in 1994?
Make the answer very short. 1.61e+07. What is the difference between the Number of enrolments of both sexes in Secondary general in 1992 and the Number of enrolments of both sexes in Secondary vocational in 1994?
Ensure brevity in your answer.  1.47e+07. What is the difference between the Number of enrolments of both sexes in Primary in 1992 and the Number of enrolments of both sexes in Secondary in 1995?
Offer a terse response. 4.75e+07. What is the difference between the Number of enrolments of both sexes in Primary in 1992 and the Number of enrolments of both sexes in Secondary general in 1995?
Ensure brevity in your answer.  4.90e+07. What is the difference between the Number of enrolments of both sexes of Primary in 1992 and the Number of enrolments of both sexes of Secondary vocational in 1995?
Provide a short and direct response. 6.57e+07. What is the difference between the Number of enrolments of both sexes in Secondary in 1992 and the Number of enrolments of both sexes in Secondary general in 1995?
Your response must be concise. -6.33e+05. What is the difference between the Number of enrolments of both sexes in Secondary in 1992 and the Number of enrolments of both sexes in Secondary vocational in 1995?
Your response must be concise. 1.60e+07. What is the difference between the Number of enrolments of both sexes of Secondary general in 1992 and the Number of enrolments of both sexes of Secondary vocational in 1995?
Offer a very short reply. 1.47e+07. What is the difference between the Number of enrolments of both sexes of Primary in 1993 and the Number of enrolments of both sexes of Secondary in 1994?
Ensure brevity in your answer.  5.11e+07. What is the difference between the Number of enrolments of both sexes of Primary in 1993 and the Number of enrolments of both sexes of Secondary general in 1994?
Your answer should be compact. 5.26e+07. What is the difference between the Number of enrolments of both sexes in Primary in 1993 and the Number of enrolments of both sexes in Secondary vocational in 1994?
Your response must be concise. 6.84e+07. What is the difference between the Number of enrolments of both sexes of Secondary in 1993 and the Number of enrolments of both sexes of Secondary general in 1994?
Ensure brevity in your answer.  7.27e+05. What is the difference between the Number of enrolments of both sexes of Secondary in 1993 and the Number of enrolments of both sexes of Secondary vocational in 1994?
Provide a succinct answer. 1.66e+07. What is the difference between the Number of enrolments of both sexes of Secondary general in 1993 and the Number of enrolments of both sexes of Secondary vocational in 1994?
Provide a short and direct response. 1.52e+07. What is the difference between the Number of enrolments of both sexes of Primary in 1993 and the Number of enrolments of both sexes of Secondary in 1995?
Provide a succinct answer. 5.02e+07. What is the difference between the Number of enrolments of both sexes of Primary in 1993 and the Number of enrolments of both sexes of Secondary general in 1995?
Provide a succinct answer. 5.17e+07. What is the difference between the Number of enrolments of both sexes in Primary in 1993 and the Number of enrolments of both sexes in Secondary vocational in 1995?
Offer a very short reply. 6.84e+07. What is the difference between the Number of enrolments of both sexes in Secondary in 1993 and the Number of enrolments of both sexes in Secondary general in 1995?
Provide a succinct answer. -1.35e+05. What is the difference between the Number of enrolments of both sexes in Secondary in 1993 and the Number of enrolments of both sexes in Secondary vocational in 1995?
Keep it short and to the point. 1.65e+07. What is the difference between the Number of enrolments of both sexes of Secondary general in 1993 and the Number of enrolments of both sexes of Secondary vocational in 1995?
Your answer should be compact. 1.51e+07. What is the difference between the Number of enrolments of both sexes of Primary in 1994 and the Number of enrolments of both sexes of Secondary in 1995?
Give a very brief answer. 5.22e+07. What is the difference between the Number of enrolments of both sexes of Primary in 1994 and the Number of enrolments of both sexes of Secondary general in 1995?
Make the answer very short. 5.37e+07. What is the difference between the Number of enrolments of both sexes in Primary in 1994 and the Number of enrolments of both sexes in Secondary vocational in 1995?
Your answer should be compact. 7.04e+07. What is the difference between the Number of enrolments of both sexes of Secondary in 1994 and the Number of enrolments of both sexes of Secondary general in 1995?
Offer a very short reply. 5.77e+05. What is the difference between the Number of enrolments of both sexes in Secondary in 1994 and the Number of enrolments of both sexes in Secondary vocational in 1995?
Your answer should be very brief. 1.72e+07. What is the difference between the Number of enrolments of both sexes of Secondary general in 1994 and the Number of enrolments of both sexes of Secondary vocational in 1995?
Provide a short and direct response. 1.58e+07. What is the average Number of enrolments of both sexes of Primary per year?
Ensure brevity in your answer.  6.68e+07. What is the average Number of enrolments of both sexes in Secondary per year?
Make the answer very short. 1.74e+07. What is the average Number of enrolments of both sexes of Secondary general per year?
Your response must be concise. 1.60e+07. What is the average Number of enrolments of both sexes in Secondary vocational per year?
Offer a terse response. 1.38e+06. In the year 1988, what is the difference between the Number of enrolments of both sexes of Primary and Number of enrolments of both sexes of Secondary?
Ensure brevity in your answer.  4.43e+07. In the year 1988, what is the difference between the Number of enrolments of both sexes of Primary and Number of enrolments of both sexes of Secondary general?
Offer a terse response. 4.57e+07. In the year 1988, what is the difference between the Number of enrolments of both sexes in Primary and Number of enrolments of both sexes in Secondary vocational?
Offer a very short reply. 5.87e+07. In the year 1988, what is the difference between the Number of enrolments of both sexes of Secondary and Number of enrolments of both sexes of Secondary general?
Ensure brevity in your answer.  1.38e+06. In the year 1988, what is the difference between the Number of enrolments of both sexes of Secondary and Number of enrolments of both sexes of Secondary vocational?
Make the answer very short. 1.44e+07. In the year 1988, what is the difference between the Number of enrolments of both sexes of Secondary general and Number of enrolments of both sexes of Secondary vocational?
Ensure brevity in your answer.  1.31e+07. In the year 1989, what is the difference between the Number of enrolments of both sexes of Primary and Number of enrolments of both sexes of Secondary?
Your response must be concise. 4.63e+07. In the year 1989, what is the difference between the Number of enrolments of both sexes of Primary and Number of enrolments of both sexes of Secondary general?
Keep it short and to the point. 4.76e+07. In the year 1989, what is the difference between the Number of enrolments of both sexes of Primary and Number of enrolments of both sexes of Secondary vocational?
Provide a succinct answer. 6.08e+07. In the year 1989, what is the difference between the Number of enrolments of both sexes in Secondary and Number of enrolments of both sexes in Secondary general?
Make the answer very short. 1.32e+06. In the year 1989, what is the difference between the Number of enrolments of both sexes of Secondary and Number of enrolments of both sexes of Secondary vocational?
Provide a succinct answer. 1.45e+07. In the year 1989, what is the difference between the Number of enrolments of both sexes of Secondary general and Number of enrolments of both sexes of Secondary vocational?
Give a very brief answer. 1.32e+07. In the year 1990, what is the difference between the Number of enrolments of both sexes in Primary and Number of enrolments of both sexes in Secondary?
Offer a very short reply. 4.67e+07. In the year 1990, what is the difference between the Number of enrolments of both sexes of Primary and Number of enrolments of both sexes of Secondary general?
Keep it short and to the point. 4.80e+07. In the year 1990, what is the difference between the Number of enrolments of both sexes in Primary and Number of enrolments of both sexes in Secondary vocational?
Keep it short and to the point. 6.17e+07. In the year 1990, what is the difference between the Number of enrolments of both sexes of Secondary and Number of enrolments of both sexes of Secondary general?
Ensure brevity in your answer.  1.34e+06. In the year 1990, what is the difference between the Number of enrolments of both sexes of Secondary and Number of enrolments of both sexes of Secondary vocational?
Keep it short and to the point. 1.51e+07. In the year 1990, what is the difference between the Number of enrolments of both sexes in Secondary general and Number of enrolments of both sexes in Secondary vocational?
Offer a very short reply. 1.37e+07. In the year 1991, what is the difference between the Number of enrolments of both sexes in Primary and Number of enrolments of both sexes in Secondary?
Provide a short and direct response. 4.86e+07. In the year 1991, what is the difference between the Number of enrolments of both sexes in Primary and Number of enrolments of both sexes in Secondary general?
Your response must be concise. 5.00e+07. In the year 1991, what is the difference between the Number of enrolments of both sexes of Primary and Number of enrolments of both sexes of Secondary vocational?
Give a very brief answer. 6.44e+07. In the year 1991, what is the difference between the Number of enrolments of both sexes of Secondary and Number of enrolments of both sexes of Secondary general?
Keep it short and to the point. 1.33e+06. In the year 1991, what is the difference between the Number of enrolments of both sexes in Secondary and Number of enrolments of both sexes in Secondary vocational?
Ensure brevity in your answer.  1.57e+07. In the year 1991, what is the difference between the Number of enrolments of both sexes in Secondary general and Number of enrolments of both sexes in Secondary vocational?
Make the answer very short. 1.44e+07. In the year 1992, what is the difference between the Number of enrolments of both sexes of Primary and Number of enrolments of both sexes of Secondary?
Provide a succinct answer. 4.97e+07. In the year 1992, what is the difference between the Number of enrolments of both sexes in Primary and Number of enrolments of both sexes in Secondary general?
Ensure brevity in your answer.  5.10e+07. In the year 1992, what is the difference between the Number of enrolments of both sexes in Primary and Number of enrolments of both sexes in Secondary vocational?
Give a very brief answer. 6.59e+07. In the year 1992, what is the difference between the Number of enrolments of both sexes of Secondary and Number of enrolments of both sexes of Secondary general?
Offer a terse response. 1.34e+06. In the year 1992, what is the difference between the Number of enrolments of both sexes of Secondary and Number of enrolments of both sexes of Secondary vocational?
Make the answer very short. 1.62e+07. In the year 1992, what is the difference between the Number of enrolments of both sexes in Secondary general and Number of enrolments of both sexes in Secondary vocational?
Provide a succinct answer. 1.48e+07. In the year 1993, what is the difference between the Number of enrolments of both sexes of Primary and Number of enrolments of both sexes of Secondary?
Offer a terse response. 5.18e+07. In the year 1993, what is the difference between the Number of enrolments of both sexes of Primary and Number of enrolments of both sexes of Secondary general?
Provide a short and direct response. 5.32e+07. In the year 1993, what is the difference between the Number of enrolments of both sexes in Primary and Number of enrolments of both sexes in Secondary vocational?
Provide a succinct answer. 6.85e+07. In the year 1993, what is the difference between the Number of enrolments of both sexes of Secondary and Number of enrolments of both sexes of Secondary general?
Keep it short and to the point. 1.38e+06. In the year 1993, what is the difference between the Number of enrolments of both sexes of Secondary and Number of enrolments of both sexes of Secondary vocational?
Offer a terse response. 1.66e+07. In the year 1993, what is the difference between the Number of enrolments of both sexes in Secondary general and Number of enrolments of both sexes in Secondary vocational?
Offer a very short reply. 1.53e+07. In the year 1994, what is the difference between the Number of enrolments of both sexes in Primary and Number of enrolments of both sexes in Secondary?
Your answer should be compact. 5.31e+07. In the year 1994, what is the difference between the Number of enrolments of both sexes in Primary and Number of enrolments of both sexes in Secondary general?
Offer a very short reply. 5.46e+07. In the year 1994, what is the difference between the Number of enrolments of both sexes of Primary and Number of enrolments of both sexes of Secondary vocational?
Your answer should be compact. 7.04e+07. In the year 1994, what is the difference between the Number of enrolments of both sexes in Secondary and Number of enrolments of both sexes in Secondary general?
Provide a short and direct response. 1.44e+06. In the year 1994, what is the difference between the Number of enrolments of both sexes in Secondary and Number of enrolments of both sexes in Secondary vocational?
Your answer should be compact. 1.73e+07. In the year 1994, what is the difference between the Number of enrolments of both sexes in Secondary general and Number of enrolments of both sexes in Secondary vocational?
Keep it short and to the point. 1.59e+07. In the year 1995, what is the difference between the Number of enrolments of both sexes of Primary and Number of enrolments of both sexes of Secondary?
Your answer should be very brief. 5.47e+07. In the year 1995, what is the difference between the Number of enrolments of both sexes of Primary and Number of enrolments of both sexes of Secondary general?
Make the answer very short. 5.62e+07. In the year 1995, what is the difference between the Number of enrolments of both sexes of Primary and Number of enrolments of both sexes of Secondary vocational?
Your answer should be very brief. 7.28e+07. In the year 1995, what is the difference between the Number of enrolments of both sexes of Secondary and Number of enrolments of both sexes of Secondary general?
Your response must be concise. 1.50e+06. In the year 1995, what is the difference between the Number of enrolments of both sexes of Secondary and Number of enrolments of both sexes of Secondary vocational?
Make the answer very short. 1.82e+07. In the year 1995, what is the difference between the Number of enrolments of both sexes in Secondary general and Number of enrolments of both sexes in Secondary vocational?
Give a very brief answer. 1.67e+07. What is the ratio of the Number of enrolments of both sexes of Primary in 1988 to that in 1989?
Make the answer very short. 0.97. What is the ratio of the Number of enrolments of both sexes of Secondary in 1988 to that in 1989?
Make the answer very short. 1. What is the ratio of the Number of enrolments of both sexes of Secondary vocational in 1988 to that in 1989?
Keep it short and to the point. 1.04. What is the ratio of the Number of enrolments of both sexes in Primary in 1988 to that in 1990?
Give a very brief answer. 0.95. What is the ratio of the Number of enrolments of both sexes in Secondary in 1988 to that in 1990?
Provide a short and direct response. 0.96. What is the ratio of the Number of enrolments of both sexes in Secondary general in 1988 to that in 1990?
Your answer should be very brief. 0.96. What is the ratio of the Number of enrolments of both sexes of Secondary vocational in 1988 to that in 1990?
Your answer should be compact. 1.03. What is the ratio of the Number of enrolments of both sexes of Primary in 1988 to that in 1991?
Give a very brief answer. 0.92. What is the ratio of the Number of enrolments of both sexes of Secondary in 1988 to that in 1991?
Give a very brief answer. 0.93. What is the ratio of the Number of enrolments of both sexes of Secondary general in 1988 to that in 1991?
Keep it short and to the point. 0.92. What is the ratio of the Number of enrolments of both sexes in Secondary vocational in 1988 to that in 1991?
Keep it short and to the point. 1.04. What is the ratio of the Number of enrolments of both sexes in Primary in 1988 to that in 1992?
Provide a succinct answer. 0.89. What is the ratio of the Number of enrolments of both sexes in Secondary in 1988 to that in 1992?
Provide a succinct answer. 0.9. What is the ratio of the Number of enrolments of both sexes of Secondary general in 1988 to that in 1992?
Provide a succinct answer. 0.89. What is the ratio of the Number of enrolments of both sexes of Secondary vocational in 1988 to that in 1992?
Keep it short and to the point. 1.03. What is the ratio of the Number of enrolments of both sexes of Primary in 1988 to that in 1993?
Keep it short and to the point. 0.86. What is the ratio of the Number of enrolments of both sexes of Secondary in 1988 to that in 1993?
Ensure brevity in your answer.  0.88. What is the ratio of the Number of enrolments of both sexes in Secondary general in 1988 to that in 1993?
Give a very brief answer. 0.87. What is the ratio of the Number of enrolments of both sexes of Secondary vocational in 1988 to that in 1993?
Offer a very short reply. 1. What is the ratio of the Number of enrolments of both sexes in Primary in 1988 to that in 1994?
Your answer should be compact. 0.84. What is the ratio of the Number of enrolments of both sexes of Secondary in 1988 to that in 1994?
Make the answer very short. 0.84. What is the ratio of the Number of enrolments of both sexes of Secondary general in 1988 to that in 1994?
Your response must be concise. 0.83. What is the ratio of the Number of enrolments of both sexes in Secondary vocational in 1988 to that in 1994?
Your answer should be very brief. 0.96. What is the ratio of the Number of enrolments of both sexes in Primary in 1988 to that in 1995?
Give a very brief answer. 0.81. What is the ratio of the Number of enrolments of both sexes of Secondary in 1988 to that in 1995?
Your answer should be very brief. 0.8. What is the ratio of the Number of enrolments of both sexes in Secondary general in 1988 to that in 1995?
Make the answer very short. 0.79. What is the ratio of the Number of enrolments of both sexes in Secondary vocational in 1988 to that in 1995?
Provide a short and direct response. 0.92. What is the ratio of the Number of enrolments of both sexes in Primary in 1989 to that in 1990?
Provide a short and direct response. 0.98. What is the ratio of the Number of enrolments of both sexes in Secondary in 1989 to that in 1990?
Give a very brief answer. 0.96. What is the ratio of the Number of enrolments of both sexes in Secondary general in 1989 to that in 1990?
Ensure brevity in your answer.  0.96. What is the ratio of the Number of enrolments of both sexes in Primary in 1989 to that in 1991?
Keep it short and to the point. 0.95. What is the ratio of the Number of enrolments of both sexes of Secondary in 1989 to that in 1991?
Give a very brief answer. 0.93. What is the ratio of the Number of enrolments of both sexes of Secondary vocational in 1989 to that in 1991?
Offer a terse response. 1. What is the ratio of the Number of enrolments of both sexes of Primary in 1989 to that in 1992?
Provide a succinct answer. 0.92. What is the ratio of the Number of enrolments of both sexes in Secondary in 1989 to that in 1992?
Your answer should be compact. 0.9. What is the ratio of the Number of enrolments of both sexes in Secondary general in 1989 to that in 1992?
Make the answer very short. 0.89. What is the ratio of the Number of enrolments of both sexes of Secondary vocational in 1989 to that in 1992?
Give a very brief answer. 0.99. What is the ratio of the Number of enrolments of both sexes in Primary in 1989 to that in 1993?
Give a very brief answer. 0.89. What is the ratio of the Number of enrolments of both sexes in Secondary in 1989 to that in 1993?
Provide a short and direct response. 0.88. What is the ratio of the Number of enrolments of both sexes of Secondary general in 1989 to that in 1993?
Keep it short and to the point. 0.87. What is the ratio of the Number of enrolments of both sexes of Secondary vocational in 1989 to that in 1993?
Your answer should be very brief. 0.96. What is the ratio of the Number of enrolments of both sexes of Primary in 1989 to that in 1994?
Your answer should be very brief. 0.86. What is the ratio of the Number of enrolments of both sexes of Secondary in 1989 to that in 1994?
Your response must be concise. 0.84. What is the ratio of the Number of enrolments of both sexes of Secondary general in 1989 to that in 1994?
Your answer should be compact. 0.84. What is the ratio of the Number of enrolments of both sexes in Secondary vocational in 1989 to that in 1994?
Make the answer very short. 0.92. What is the ratio of the Number of enrolments of both sexes of Primary in 1989 to that in 1995?
Your answer should be compact. 0.84. What is the ratio of the Number of enrolments of both sexes of Secondary in 1989 to that in 1995?
Keep it short and to the point. 0.8. What is the ratio of the Number of enrolments of both sexes of Secondary general in 1989 to that in 1995?
Offer a very short reply. 0.8. What is the ratio of the Number of enrolments of both sexes in Secondary vocational in 1989 to that in 1995?
Provide a short and direct response. 0.88. What is the ratio of the Number of enrolments of both sexes in Primary in 1990 to that in 1991?
Keep it short and to the point. 0.96. What is the ratio of the Number of enrolments of both sexes of Secondary in 1990 to that in 1991?
Give a very brief answer. 0.96. What is the ratio of the Number of enrolments of both sexes in Secondary general in 1990 to that in 1991?
Provide a short and direct response. 0.96. What is the ratio of the Number of enrolments of both sexes in Secondary vocational in 1990 to that in 1991?
Your answer should be very brief. 1.01. What is the ratio of the Number of enrolments of both sexes in Primary in 1990 to that in 1992?
Keep it short and to the point. 0.94. What is the ratio of the Number of enrolments of both sexes in Secondary in 1990 to that in 1992?
Provide a short and direct response. 0.94. What is the ratio of the Number of enrolments of both sexes in Secondary general in 1990 to that in 1992?
Provide a succinct answer. 0.93. What is the ratio of the Number of enrolments of both sexes of Primary in 1990 to that in 1993?
Offer a terse response. 0.9. What is the ratio of the Number of enrolments of both sexes in Secondary in 1990 to that in 1993?
Your answer should be very brief. 0.91. What is the ratio of the Number of enrolments of both sexes in Secondary general in 1990 to that in 1993?
Provide a succinct answer. 0.91. What is the ratio of the Number of enrolments of both sexes in Secondary vocational in 1990 to that in 1993?
Provide a short and direct response. 0.97. What is the ratio of the Number of enrolments of both sexes in Primary in 1990 to that in 1994?
Keep it short and to the point. 0.88. What is the ratio of the Number of enrolments of both sexes of Secondary in 1990 to that in 1994?
Offer a terse response. 0.88. What is the ratio of the Number of enrolments of both sexes of Secondary general in 1990 to that in 1994?
Make the answer very short. 0.87. What is the ratio of the Number of enrolments of both sexes in Secondary vocational in 1990 to that in 1994?
Offer a very short reply. 0.93. What is the ratio of the Number of enrolments of both sexes of Primary in 1990 to that in 1995?
Your answer should be very brief. 0.85. What is the ratio of the Number of enrolments of both sexes in Secondary in 1990 to that in 1995?
Offer a terse response. 0.83. What is the ratio of the Number of enrolments of both sexes of Secondary general in 1990 to that in 1995?
Offer a terse response. 0.83. What is the ratio of the Number of enrolments of both sexes in Secondary vocational in 1990 to that in 1995?
Provide a short and direct response. 0.89. What is the ratio of the Number of enrolments of both sexes in Primary in 1991 to that in 1992?
Give a very brief answer. 0.98. What is the ratio of the Number of enrolments of both sexes of Secondary in 1991 to that in 1992?
Ensure brevity in your answer.  0.97. What is the ratio of the Number of enrolments of both sexes of Secondary general in 1991 to that in 1992?
Offer a terse response. 0.97. What is the ratio of the Number of enrolments of both sexes of Primary in 1991 to that in 1993?
Your answer should be very brief. 0.94. What is the ratio of the Number of enrolments of both sexes of Secondary in 1991 to that in 1993?
Give a very brief answer. 0.95. What is the ratio of the Number of enrolments of both sexes in Secondary general in 1991 to that in 1993?
Make the answer very short. 0.95. What is the ratio of the Number of enrolments of both sexes of Secondary vocational in 1991 to that in 1993?
Offer a very short reply. 0.96. What is the ratio of the Number of enrolments of both sexes of Primary in 1991 to that in 1994?
Your answer should be very brief. 0.91. What is the ratio of the Number of enrolments of both sexes of Secondary in 1991 to that in 1994?
Your response must be concise. 0.91. What is the ratio of the Number of enrolments of both sexes in Secondary general in 1991 to that in 1994?
Offer a very short reply. 0.91. What is the ratio of the Number of enrolments of both sexes of Secondary vocational in 1991 to that in 1994?
Give a very brief answer. 0.92. What is the ratio of the Number of enrolments of both sexes in Primary in 1991 to that in 1995?
Your answer should be very brief. 0.88. What is the ratio of the Number of enrolments of both sexes in Secondary in 1991 to that in 1995?
Offer a very short reply. 0.87. What is the ratio of the Number of enrolments of both sexes of Secondary general in 1991 to that in 1995?
Your answer should be compact. 0.87. What is the ratio of the Number of enrolments of both sexes of Secondary vocational in 1991 to that in 1995?
Your answer should be compact. 0.88. What is the ratio of the Number of enrolments of both sexes in Primary in 1992 to that in 1993?
Your response must be concise. 0.96. What is the ratio of the Number of enrolments of both sexes in Secondary in 1992 to that in 1993?
Offer a very short reply. 0.97. What is the ratio of the Number of enrolments of both sexes of Secondary general in 1992 to that in 1993?
Keep it short and to the point. 0.97. What is the ratio of the Number of enrolments of both sexes in Secondary vocational in 1992 to that in 1993?
Provide a succinct answer. 0.97. What is the ratio of the Number of enrolments of both sexes of Primary in 1992 to that in 1994?
Your response must be concise. 0.94. What is the ratio of the Number of enrolments of both sexes of Secondary in 1992 to that in 1994?
Your response must be concise. 0.94. What is the ratio of the Number of enrolments of both sexes of Secondary general in 1992 to that in 1994?
Provide a short and direct response. 0.94. What is the ratio of the Number of enrolments of both sexes of Secondary vocational in 1992 to that in 1994?
Your response must be concise. 0.93. What is the ratio of the Number of enrolments of both sexes in Primary in 1992 to that in 1995?
Your response must be concise. 0.9. What is the ratio of the Number of enrolments of both sexes of Secondary in 1992 to that in 1995?
Offer a very short reply. 0.89. What is the ratio of the Number of enrolments of both sexes in Secondary general in 1992 to that in 1995?
Ensure brevity in your answer.  0.89. What is the ratio of the Number of enrolments of both sexes in Secondary vocational in 1992 to that in 1995?
Offer a terse response. 0.89. What is the ratio of the Number of enrolments of both sexes of Primary in 1993 to that in 1994?
Provide a short and direct response. 0.97. What is the ratio of the Number of enrolments of both sexes in Secondary general in 1993 to that in 1994?
Offer a terse response. 0.96. What is the ratio of the Number of enrolments of both sexes in Secondary vocational in 1993 to that in 1994?
Your answer should be very brief. 0.96. What is the ratio of the Number of enrolments of both sexes of Primary in 1993 to that in 1995?
Make the answer very short. 0.94. What is the ratio of the Number of enrolments of both sexes of Secondary general in 1993 to that in 1995?
Offer a very short reply. 0.92. What is the ratio of the Number of enrolments of both sexes of Secondary vocational in 1993 to that in 1995?
Your answer should be very brief. 0.92. What is the ratio of the Number of enrolments of both sexes of Primary in 1994 to that in 1995?
Make the answer very short. 0.97. What is the ratio of the Number of enrolments of both sexes of Secondary in 1994 to that in 1995?
Provide a short and direct response. 0.95. What is the ratio of the Number of enrolments of both sexes in Secondary general in 1994 to that in 1995?
Your response must be concise. 0.95. What is the ratio of the Number of enrolments of both sexes in Secondary vocational in 1994 to that in 1995?
Your answer should be very brief. 0.96. What is the difference between the highest and the second highest Number of enrolments of both sexes of Primary?
Give a very brief answer. 2.46e+06. What is the difference between the highest and the second highest Number of enrolments of both sexes in Secondary?
Offer a very short reply. 9.25e+05. What is the difference between the highest and the second highest Number of enrolments of both sexes in Secondary general?
Give a very brief answer. 8.62e+05. What is the difference between the highest and the second highest Number of enrolments of both sexes in Secondary vocational?
Offer a very short reply. 6.39e+04. What is the difference between the highest and the lowest Number of enrolments of both sexes of Primary?
Ensure brevity in your answer.  1.42e+07. What is the difference between the highest and the lowest Number of enrolments of both sexes in Secondary?
Provide a succinct answer. 3.86e+06. What is the difference between the highest and the lowest Number of enrolments of both sexes in Secondary general?
Keep it short and to the point. 3.73e+06. What is the difference between the highest and the lowest Number of enrolments of both sexes in Secondary vocational?
Ensure brevity in your answer.  1.79e+05. 